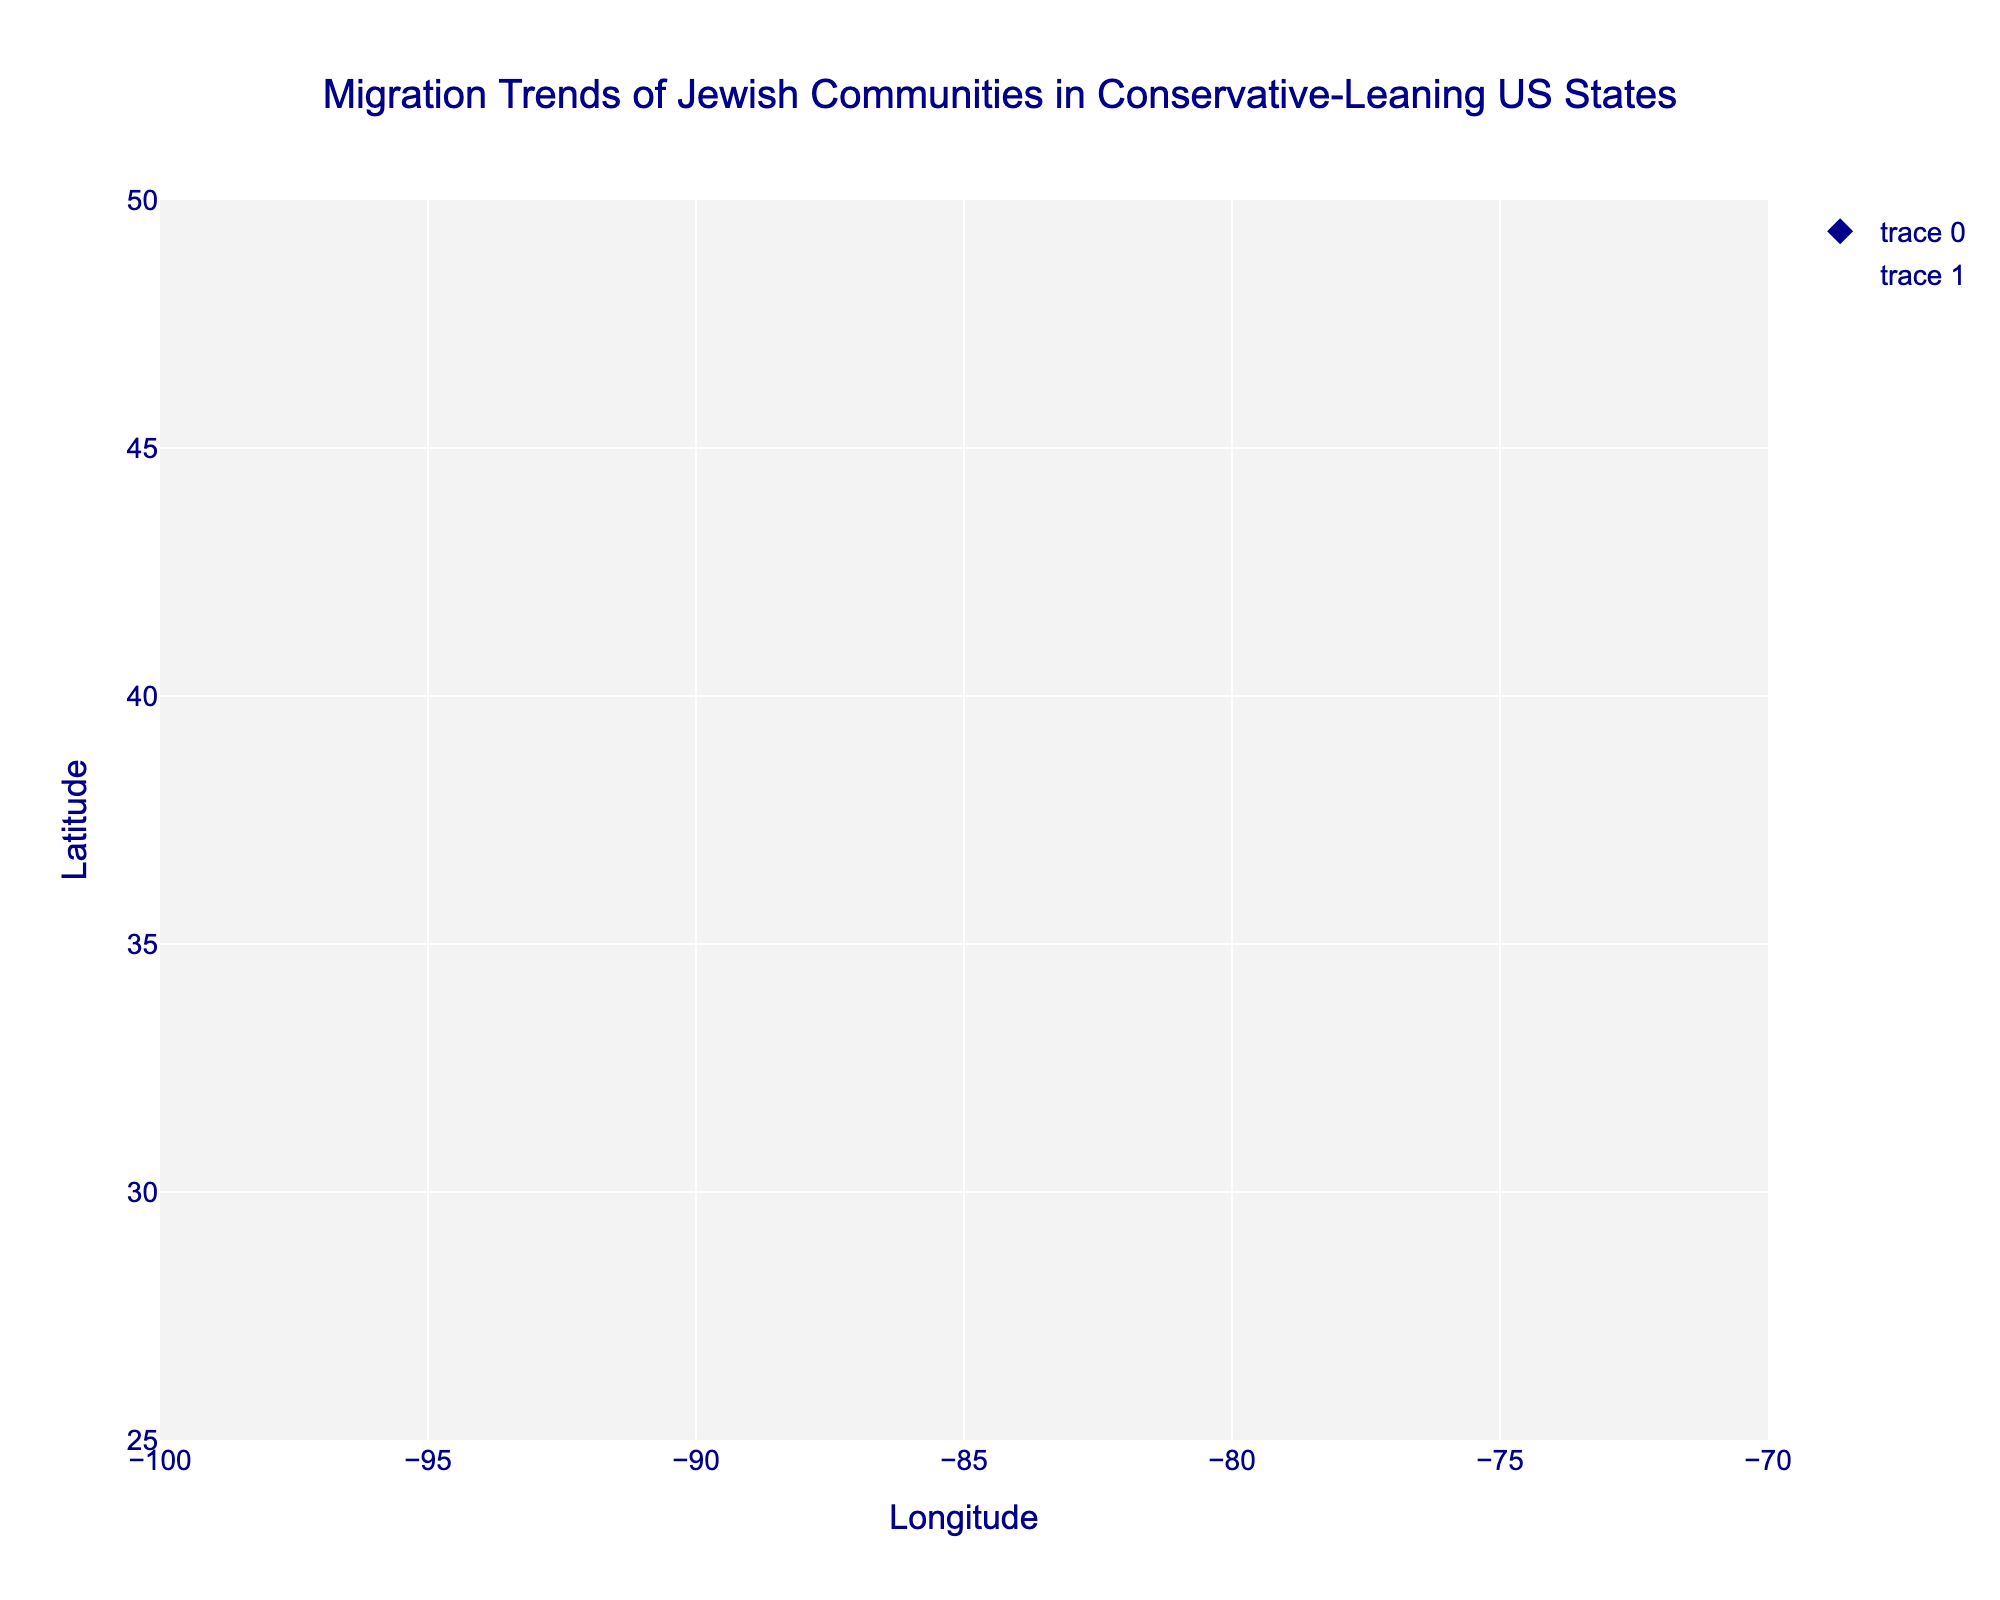What's the title of the plot? The title of the plot is located at the top center of the figure, and is often the most prominent text. By looking at the figure, we can easily identify the title.
Answer: Migration Trends of Jewish Communities in Conservative-Leaning US States What are the x-axis and y-axis titles? The x-axis and y-axis titles are typically found below the x-axis and to the left of the y-axis, respectively.
Answer: Longitude (x-axis), Latitude (y-axis) How many states are represented in this plot? Counting the number of state names displayed as text labels on the figure allows us to determine how many states are represented.
Answer: 10 Which state has the largest outward migration trend? By observing the lengths and directions of the arrows, the state with the longest arrow pointing away from the original location indicates the largest outward migration.
Answer: Illinois Which state shows an inward migration trend? States with arrows pointing towards the origin (negative u or v components) indicate inward migration. By inspecting the arrow directions, we can identify such states.
Answer: None In which direction is the migration trend for Tennessee? By looking at the direction of the arrow starting from Tennessee, we can determine the general direction of the migration trend.
Answer: Southwest What is the approximate length of the arrow for Texas? To estimate the length of the arrow, observe the distance between the start and end points of the arrow for Texas on the figure.
Answer: 0.4 units Compare the migration trends between Georgia and North Carolina. Which state has a stronger outward migration? By comparing the lengths of the arrows originating from Georgia and North Carolina, we can determine which state has a more pronounced outward migration.
Answer: North Carolina For Indiana, what are the components of the migration trend vector (u, v)? Since vectors u and v are visualized as arrows, locating Indiana's arrow and measuring its direction and length allows us to gauge these components.
Answer: (0.3, 0.2) Does any state show a migration vector directly northward? A northward migration vector would have a zero x-component and a positive y-component (u=0, v>0). We inspect all arrows to find such a vector.
Answer: No 